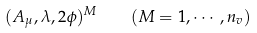Convert formula to latex. <formula><loc_0><loc_0><loc_500><loc_500>( A _ { \mu } , \lambda , 2 \phi ) ^ { M } \quad ( M = 1 , \cdots , n _ { v } )</formula> 